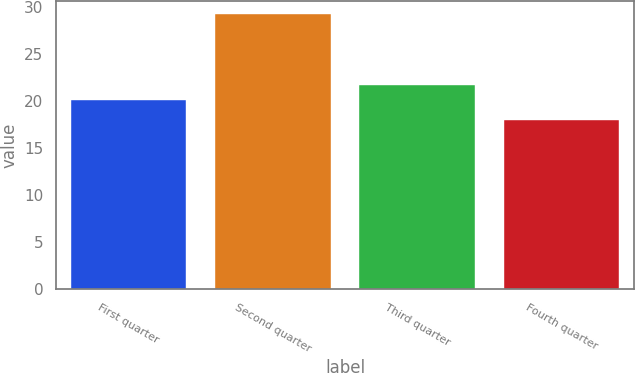Convert chart. <chart><loc_0><loc_0><loc_500><loc_500><bar_chart><fcel>First quarter<fcel>Second quarter<fcel>Third quarter<fcel>Fourth quarter<nl><fcel>20.08<fcel>29.19<fcel>21.7<fcel>17.96<nl></chart> 